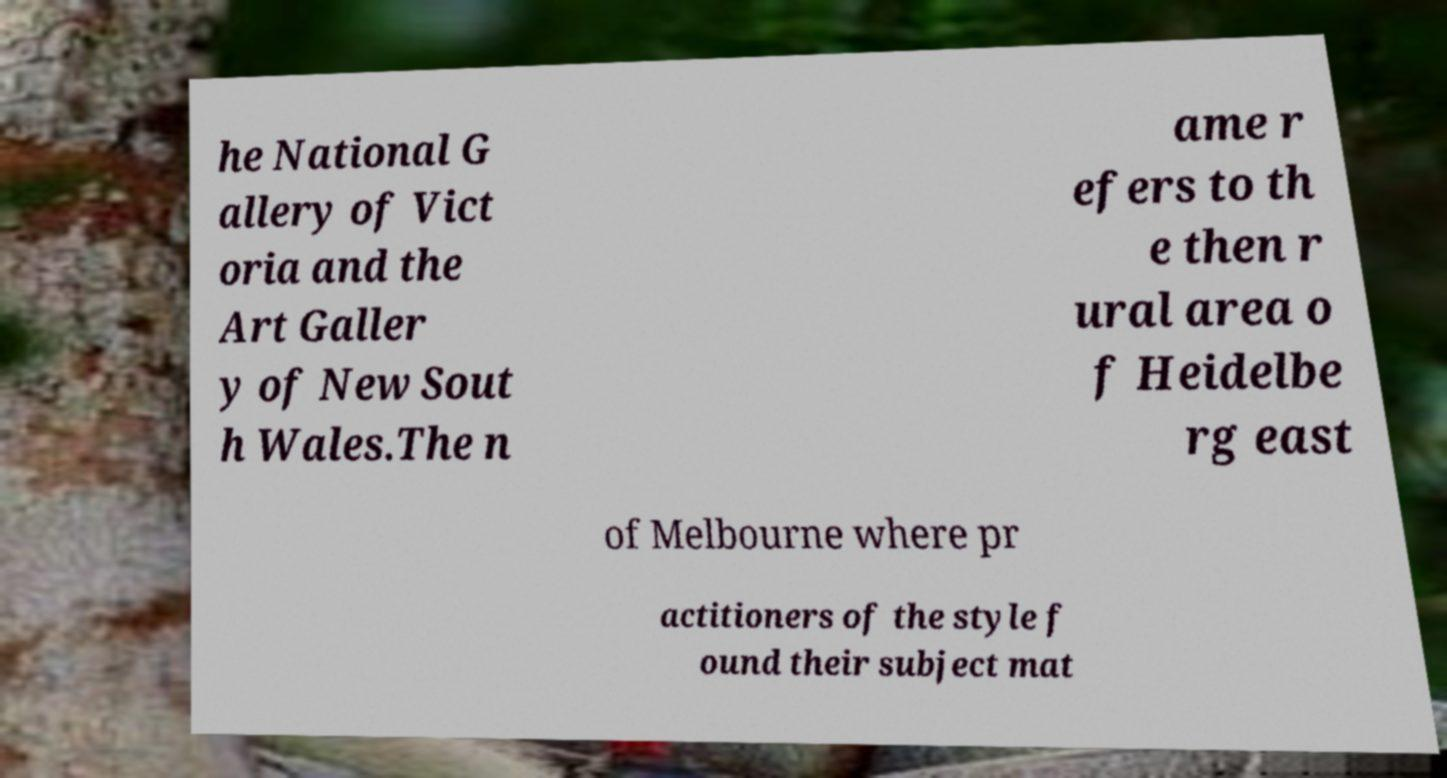Could you extract and type out the text from this image? he National G allery of Vict oria and the Art Galler y of New Sout h Wales.The n ame r efers to th e then r ural area o f Heidelbe rg east of Melbourne where pr actitioners of the style f ound their subject mat 